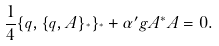Convert formula to latex. <formula><loc_0><loc_0><loc_500><loc_500>\frac { 1 } { 4 } \{ q , \{ q , A \} _ { ^ { * } } \} _ { ^ { * } } + \alpha ^ { \prime } g A ^ { * } A = 0 .</formula> 